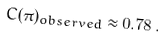<formula> <loc_0><loc_0><loc_500><loc_500>C ( \pi ) _ { o b s e r v e d } \approx 0 . 7 8 \, .</formula> 